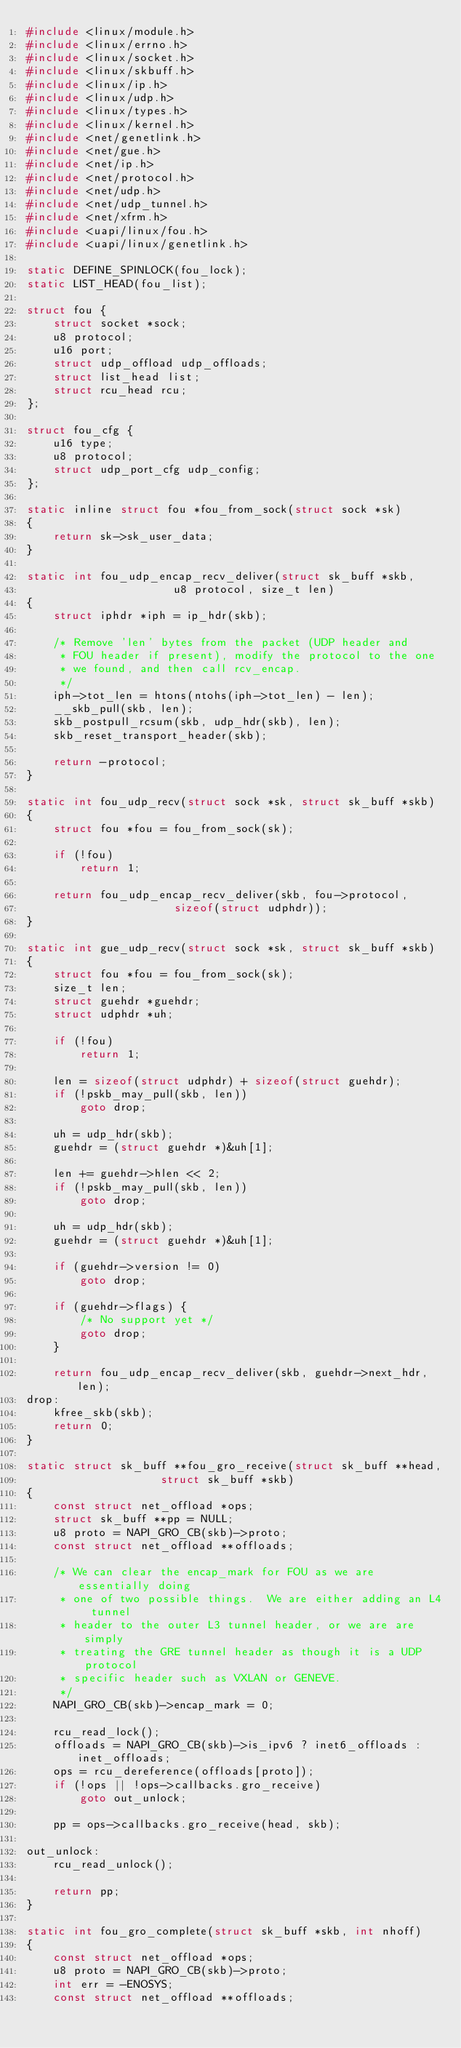<code> <loc_0><loc_0><loc_500><loc_500><_C_>#include <linux/module.h>
#include <linux/errno.h>
#include <linux/socket.h>
#include <linux/skbuff.h>
#include <linux/ip.h>
#include <linux/udp.h>
#include <linux/types.h>
#include <linux/kernel.h>
#include <net/genetlink.h>
#include <net/gue.h>
#include <net/ip.h>
#include <net/protocol.h>
#include <net/udp.h>
#include <net/udp_tunnel.h>
#include <net/xfrm.h>
#include <uapi/linux/fou.h>
#include <uapi/linux/genetlink.h>

static DEFINE_SPINLOCK(fou_lock);
static LIST_HEAD(fou_list);

struct fou {
	struct socket *sock;
	u8 protocol;
	u16 port;
	struct udp_offload udp_offloads;
	struct list_head list;
	struct rcu_head rcu;
};

struct fou_cfg {
	u16 type;
	u8 protocol;
	struct udp_port_cfg udp_config;
};

static inline struct fou *fou_from_sock(struct sock *sk)
{
	return sk->sk_user_data;
}

static int fou_udp_encap_recv_deliver(struct sk_buff *skb,
				      u8 protocol, size_t len)
{
	struct iphdr *iph = ip_hdr(skb);

	/* Remove 'len' bytes from the packet (UDP header and
	 * FOU header if present), modify the protocol to the one
	 * we found, and then call rcv_encap.
	 */
	iph->tot_len = htons(ntohs(iph->tot_len) - len);
	__skb_pull(skb, len);
	skb_postpull_rcsum(skb, udp_hdr(skb), len);
	skb_reset_transport_header(skb);

	return -protocol;
}

static int fou_udp_recv(struct sock *sk, struct sk_buff *skb)
{
	struct fou *fou = fou_from_sock(sk);

	if (!fou)
		return 1;

	return fou_udp_encap_recv_deliver(skb, fou->protocol,
					  sizeof(struct udphdr));
}

static int gue_udp_recv(struct sock *sk, struct sk_buff *skb)
{
	struct fou *fou = fou_from_sock(sk);
	size_t len;
	struct guehdr *guehdr;
	struct udphdr *uh;

	if (!fou)
		return 1;

	len = sizeof(struct udphdr) + sizeof(struct guehdr);
	if (!pskb_may_pull(skb, len))
		goto drop;

	uh = udp_hdr(skb);
	guehdr = (struct guehdr *)&uh[1];

	len += guehdr->hlen << 2;
	if (!pskb_may_pull(skb, len))
		goto drop;

	uh = udp_hdr(skb);
	guehdr = (struct guehdr *)&uh[1];

	if (guehdr->version != 0)
		goto drop;

	if (guehdr->flags) {
		/* No support yet */
		goto drop;
	}

	return fou_udp_encap_recv_deliver(skb, guehdr->next_hdr, len);
drop:
	kfree_skb(skb);
	return 0;
}

static struct sk_buff **fou_gro_receive(struct sk_buff **head,
					struct sk_buff *skb)
{
	const struct net_offload *ops;
	struct sk_buff **pp = NULL;
	u8 proto = NAPI_GRO_CB(skb)->proto;
	const struct net_offload **offloads;

	/* We can clear the encap_mark for FOU as we are essentially doing
	 * one of two possible things.  We are either adding an L4 tunnel
	 * header to the outer L3 tunnel header, or we are are simply
	 * treating the GRE tunnel header as though it is a UDP protocol
	 * specific header such as VXLAN or GENEVE.
	 */
	NAPI_GRO_CB(skb)->encap_mark = 0;

	rcu_read_lock();
	offloads = NAPI_GRO_CB(skb)->is_ipv6 ? inet6_offloads : inet_offloads;
	ops = rcu_dereference(offloads[proto]);
	if (!ops || !ops->callbacks.gro_receive)
		goto out_unlock;

	pp = ops->callbacks.gro_receive(head, skb);

out_unlock:
	rcu_read_unlock();

	return pp;
}

static int fou_gro_complete(struct sk_buff *skb, int nhoff)
{
	const struct net_offload *ops;
	u8 proto = NAPI_GRO_CB(skb)->proto;
	int err = -ENOSYS;
	const struct net_offload **offloads;
</code> 